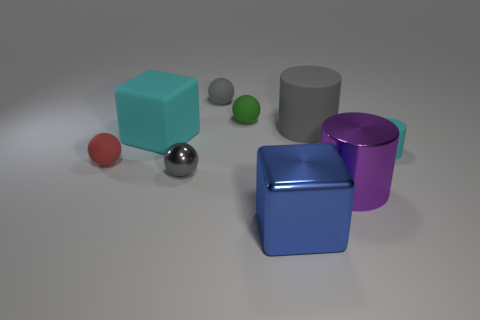What is the size of the object that is the same color as the large rubber block?
Your answer should be compact. Small. There is a large thing that is the same color as the small rubber cylinder; what is its shape?
Ensure brevity in your answer.  Cube. Is there anything else that has the same color as the tiny cylinder?
Offer a very short reply. Yes. Are there any small green cylinders?
Offer a very short reply. No. There is a small gray object that is the same material as the big gray thing; what shape is it?
Your response must be concise. Sphere. What material is the big thing that is to the left of the big blue thing?
Keep it short and to the point. Rubber. There is a big cylinder that is behind the cyan rubber cylinder; does it have the same color as the big shiny cube?
Make the answer very short. No. What is the size of the block that is behind the small sphere left of the matte cube?
Offer a very short reply. Large. Is the number of red rubber things that are in front of the red object greater than the number of tiny red balls?
Provide a short and direct response. No. There is a thing that is behind the green sphere; does it have the same size as the large cyan object?
Make the answer very short. No. 